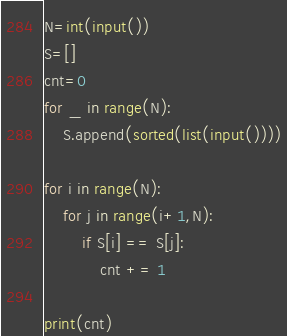<code> <loc_0><loc_0><loc_500><loc_500><_Python_>N=int(input())
S=[]
cnt=0
for _ in range(N):
    S.append(sorted(list(input())))
    
for i in range(N):
    for j in range(i+1,N):
        if S[i] == S[j]:
            cnt += 1

print(cnt)</code> 